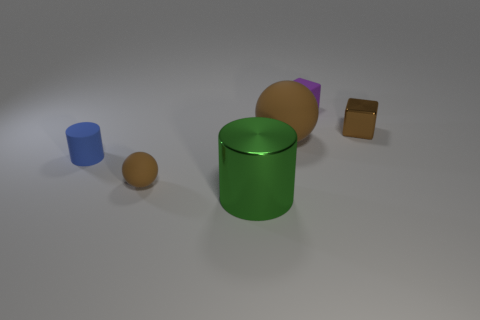Imagine these objects are part of a child's playset. Can you create a story involving these objects? Certainly! Once upon a time in a vibrant playroom, the green cylinder, known as the Guardian of the Fields, protected the magical seeds inside it, represented by the orange sphere. The blue cylinder was the Well of Wisdom, quenching the curiosity of all who approached. The purple block, called the Tablet of Tales, held stories of ancient times, and the small brown cube was the Key to Dimensions, unlocking different play areas. Together, they created a world of wonder and learning for the children who played with them. 